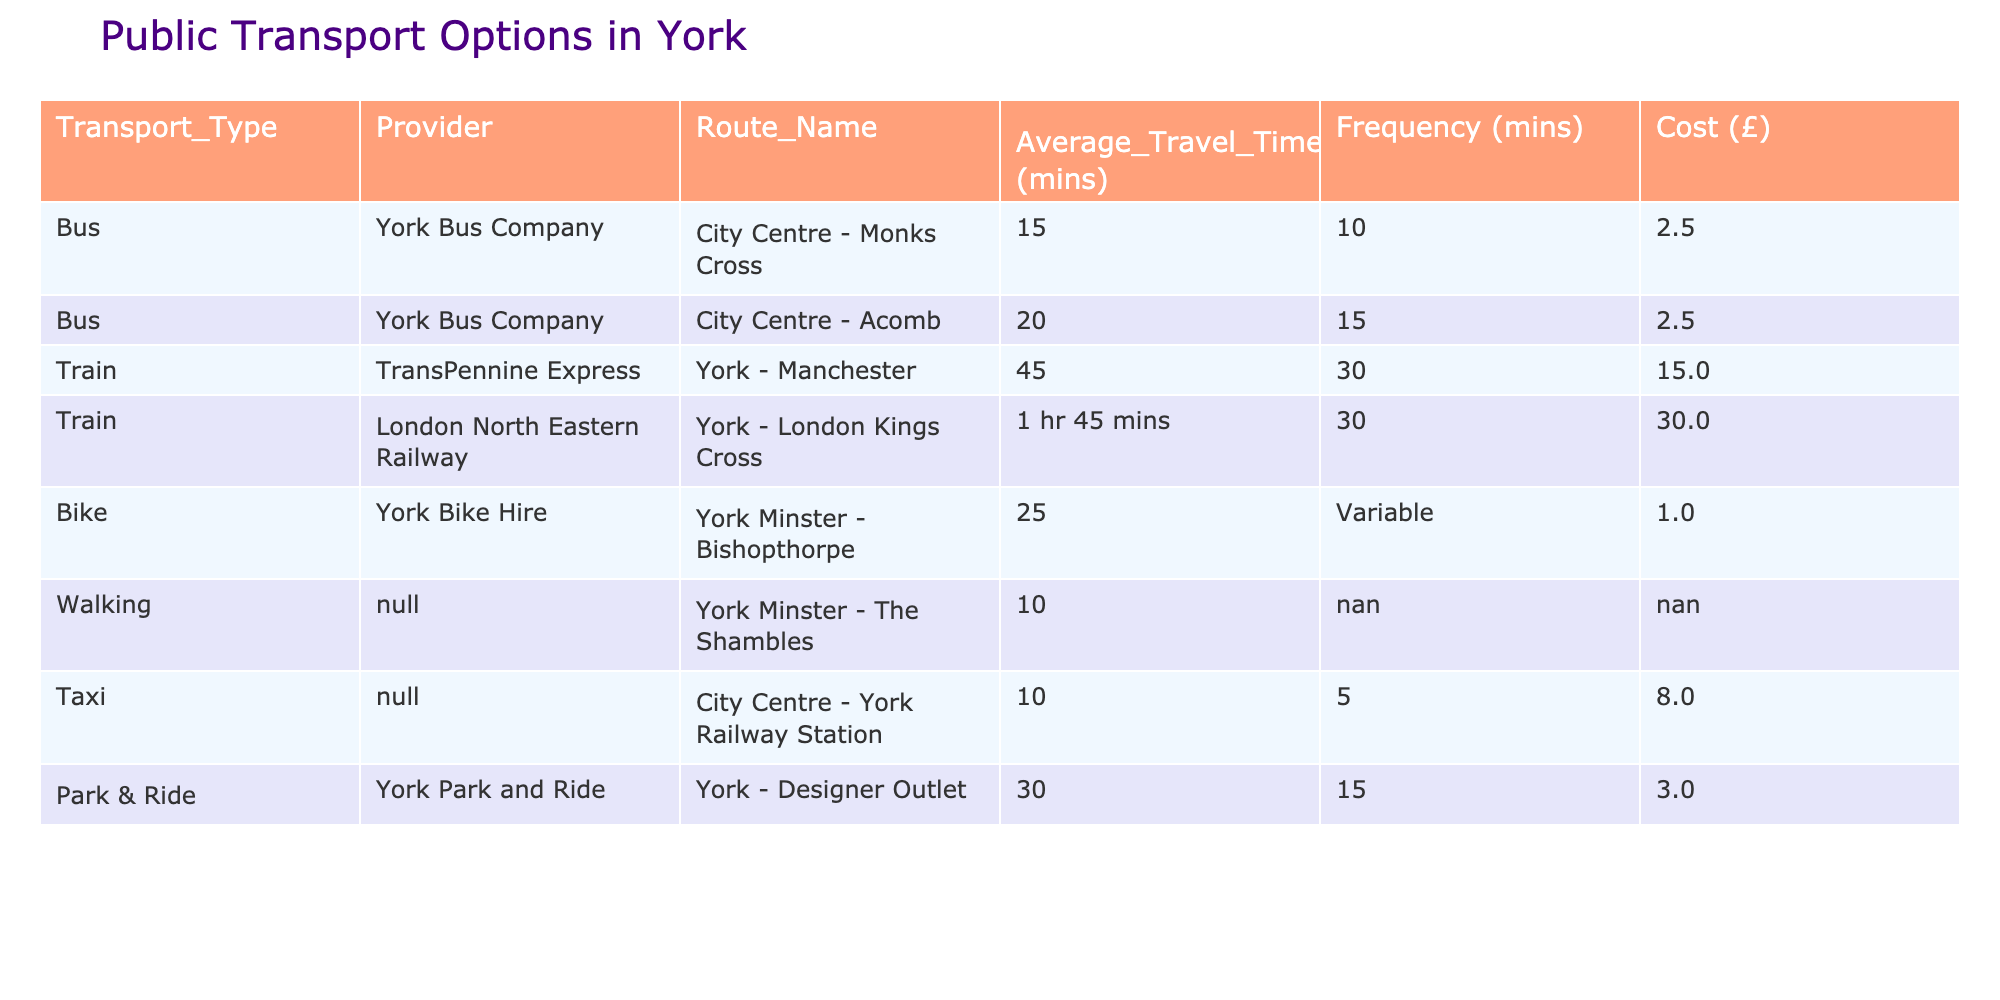What is the average travel time for a bus in York? To find the average travel time for buses, we look at the average travel times listed for each bus route: 15 minutes for the City Centre - Monks Cross route and 20 minutes for the City Centre - Acomb route. We sum these (15 + 20) = 35 minutes and then divide by the number of bus routes, which is 2. Therefore, the average travel time for a bus is 35/2 = 17.5 minutes.
Answer: 17.5 minutes What is the cost of taking a train from York to London Kings Cross? According to the table, the cost listed for the train from York to London Kings Cross is £30.00.
Answer: £30.00 Is biking from York Minster to Bishopthorpe cheaper than taking a bus? The cost for biking is £1.00 while the cost for both bus options is £2.50. Since £1.00 is less than £2.50, biking is indeed cheaper than taking a bus.
Answer: Yes What is the total frequency of the Park & Ride service? The frequency for the Park & Ride service is stated as 15 minutes. This means that buses are available every 15 minutes for this service.
Answer: 15 minutes Which transport type has the shortest average travel time? From the table, the average travel times are 15 minutes for the bus from the City Centre to Monks Cross and 10 minutes for walking to the Shambles. Since 10 minutes is less than 15 minutes, walking has the shortest average travel time.
Answer: Walking What is the combination of average travel time for the bus to Monks Cross and the taxi from the City Centre to the railway station? The average travel time for the bus to Monks Cross is 15 minutes and for the taxi, it is 10 minutes. To find the combined average travel time, we add these: 15 + 10 = 25 minutes.
Answer: 25 minutes Is it true that the average cost of all transport options in York exceeds £5.00? We list the costs: Buses (£2.50), Train (£15.00), Bike (£1.00), Walking (N/A), Taxi (£8.00), Park & Ride (£3.00). Ignoring walking (N/A), we calculate the average by summing these costs (2.50 + 15.00 + 1.00 + 8.00 + 3.00) = 29.50 and dividing by the number of options (5), which gives us 29.50/5 = 5.90. Since £5.90 is more than £5.00, the statement is true.
Answer: Yes What is the travel time for the train from York to Manchester? From the table, the average travel time for the train from York to Manchester is listed as 45 minutes.
Answer: 45 minutes How many minutes on average do you wait for the bus to Acomb? The frequency for the bus to Acomb is 15 minutes, which indicates you would wait approximately 15 minutes on average for the next bus to this destination.
Answer: 15 minutes 